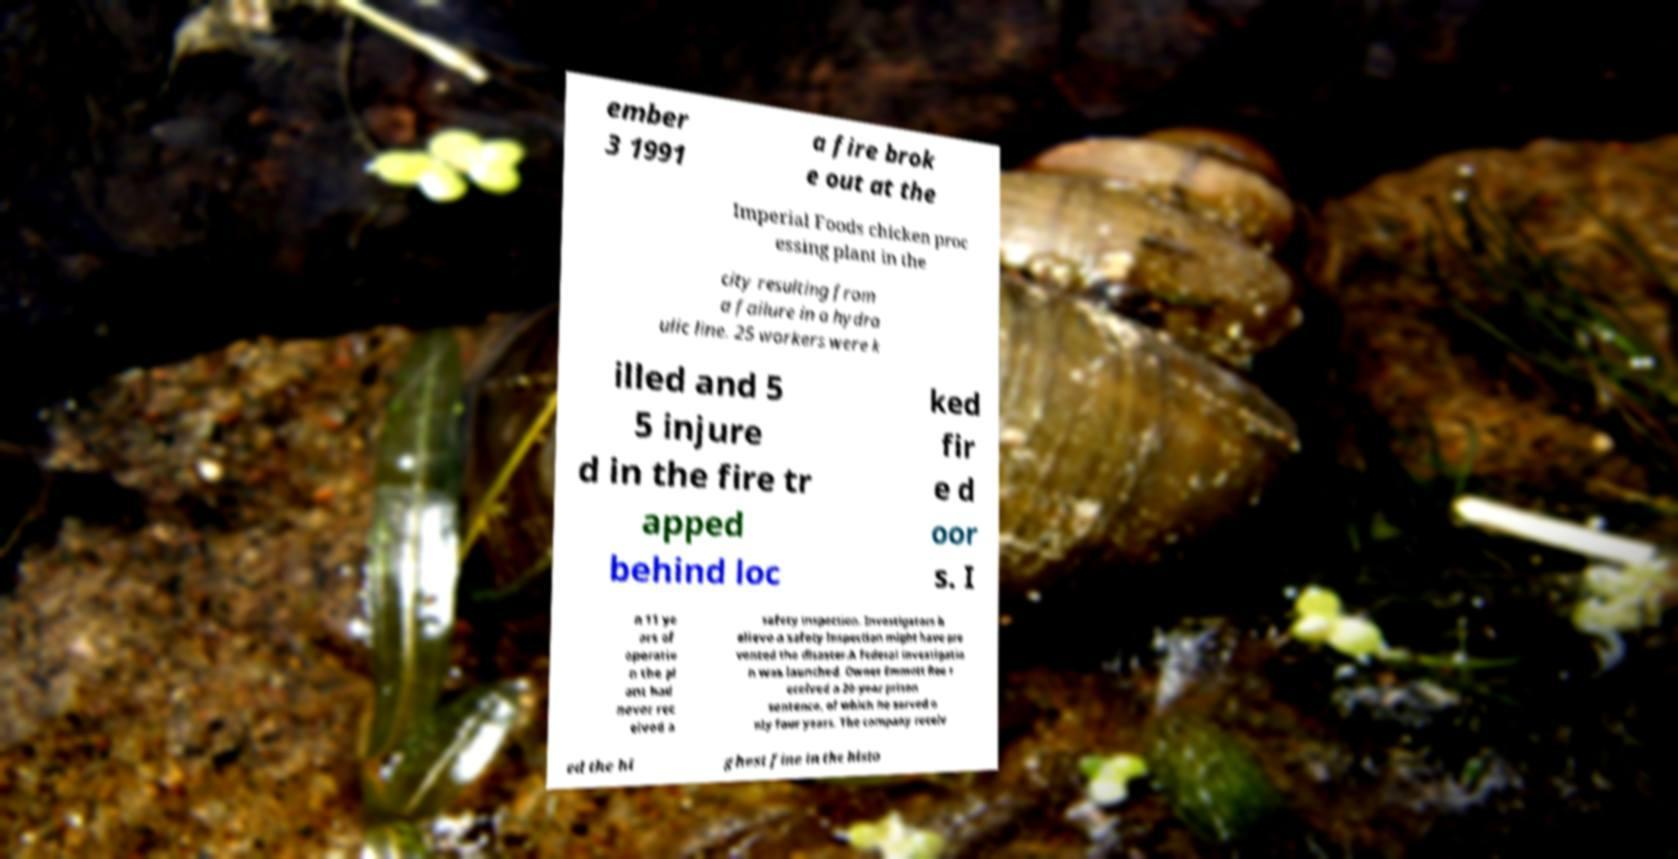I need the written content from this picture converted into text. Can you do that? ember 3 1991 a fire brok e out at the Imperial Foods chicken proc essing plant in the city resulting from a failure in a hydra ulic line. 25 workers were k illed and 5 5 injure d in the fire tr apped behind loc ked fir e d oor s. I n 11 ye ars of operatio n the pl ant had never rec eived a safety inspection. Investigators b elieve a safety inspection might have pre vented the disaster.A federal investigatio n was launched. Owner Emmett Roe r eceived a 20-year prison sentence, of which he served o nly four years. The company receiv ed the hi ghest fine in the histo 